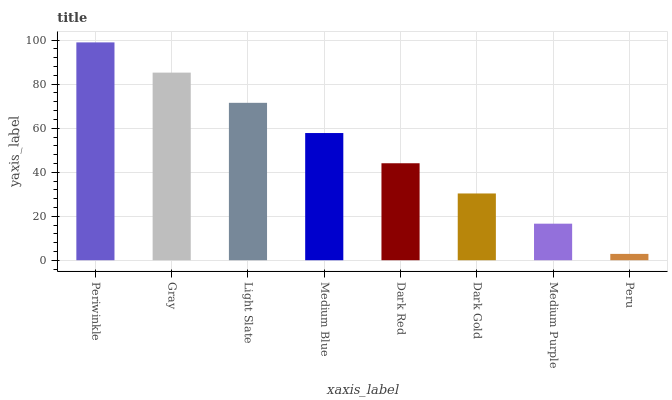Is Peru the minimum?
Answer yes or no. Yes. Is Periwinkle the maximum?
Answer yes or no. Yes. Is Gray the minimum?
Answer yes or no. No. Is Gray the maximum?
Answer yes or no. No. Is Periwinkle greater than Gray?
Answer yes or no. Yes. Is Gray less than Periwinkle?
Answer yes or no. Yes. Is Gray greater than Periwinkle?
Answer yes or no. No. Is Periwinkle less than Gray?
Answer yes or no. No. Is Medium Blue the high median?
Answer yes or no. Yes. Is Dark Red the low median?
Answer yes or no. Yes. Is Light Slate the high median?
Answer yes or no. No. Is Medium Blue the low median?
Answer yes or no. No. 